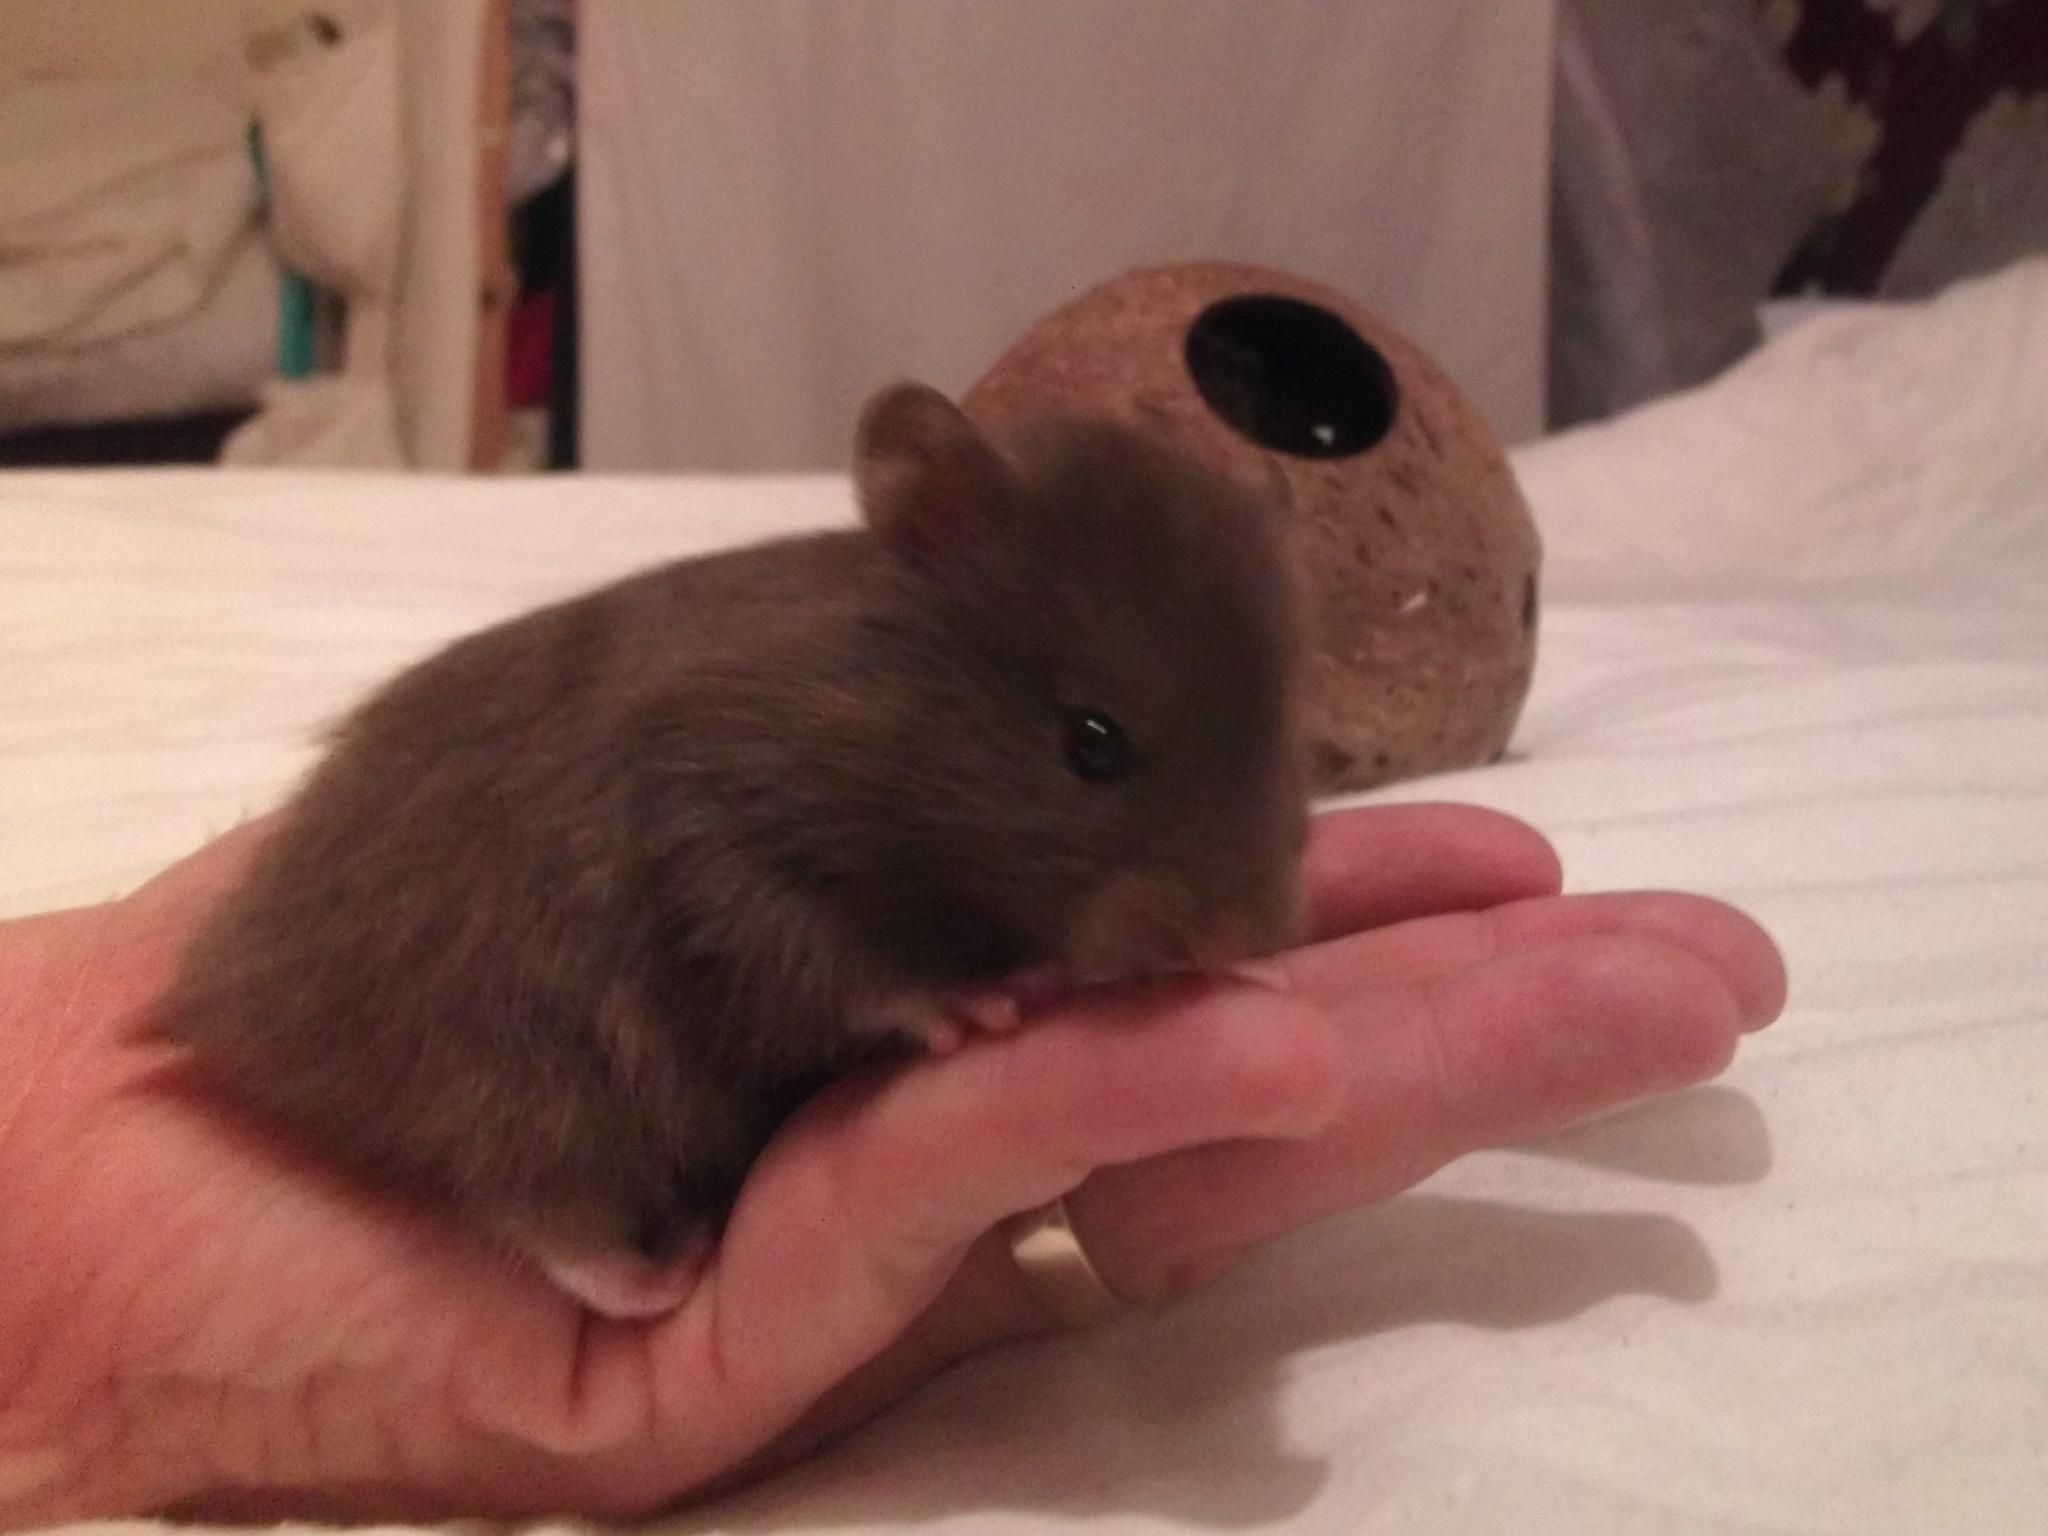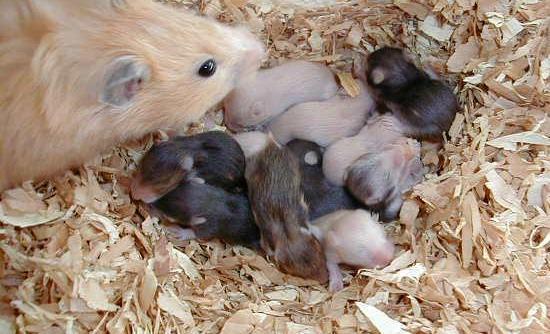The first image is the image on the left, the second image is the image on the right. Given the left and right images, does the statement "There are more hamsters in the right image than in the left image." hold true? Answer yes or no. Yes. The first image is the image on the left, the second image is the image on the right. For the images displayed, is the sentence "The left image contains only non-newborn mouse-like pets, and the right image shows all mouse-like pets on shredded bedding." factually correct? Answer yes or no. Yes. 